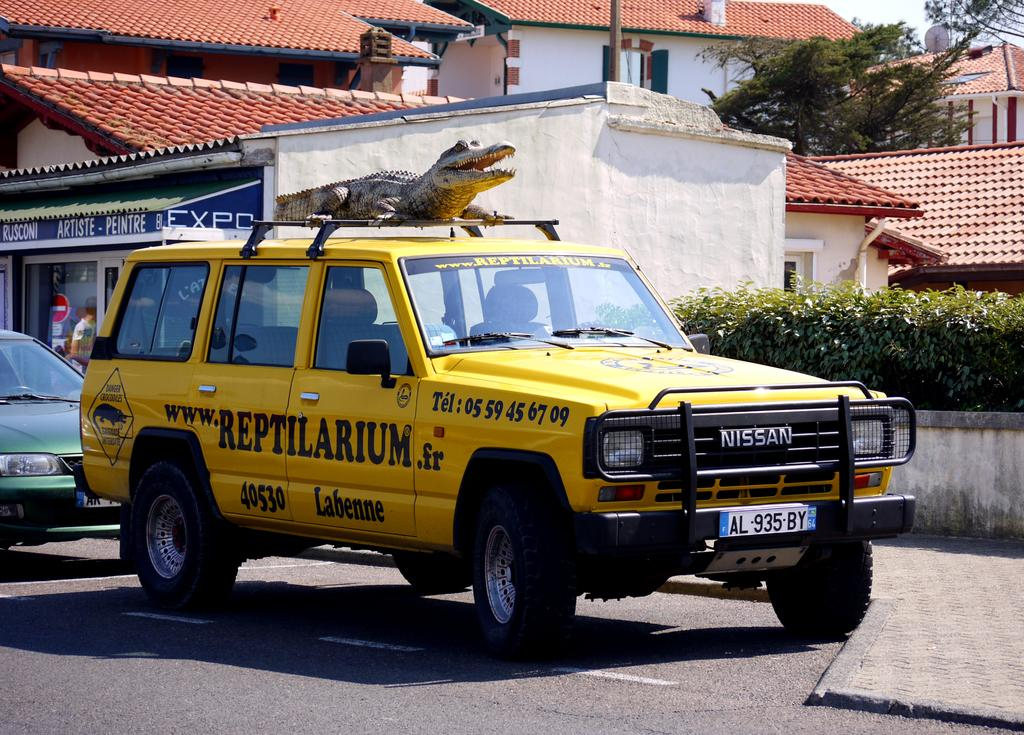<image>
Relay a brief, clear account of the picture shown. Yellow Nissan that has www.Retilarium.fr in black letters on the right side. 